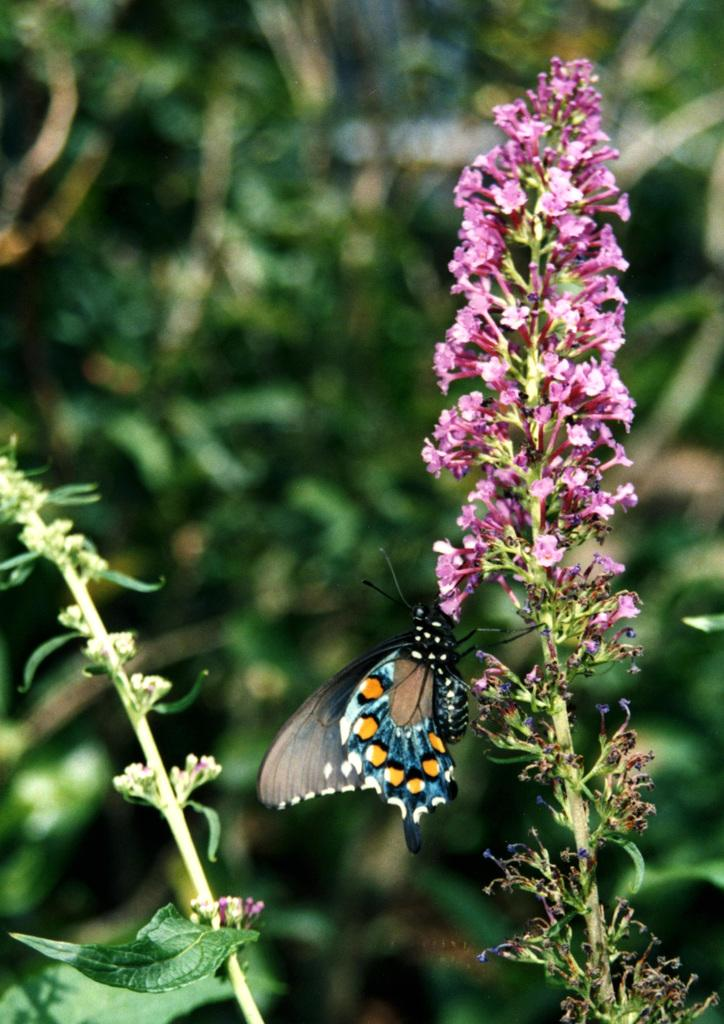What type of living organisms can be seen in the image? There are flowers and a butterfly in the image. What are the flowers associated with? The flowers are associated with plants. Where is the butterfly located in relation to the flowers? The butterfly is near the flowers. What type of dirt can be seen on the butterfly's wings in the image? There is no dirt visible on the butterfly's wings in the image. How does the butterfly start its journey in the image? The image does not show the butterfly starting its journey; it is already near the flowers. 